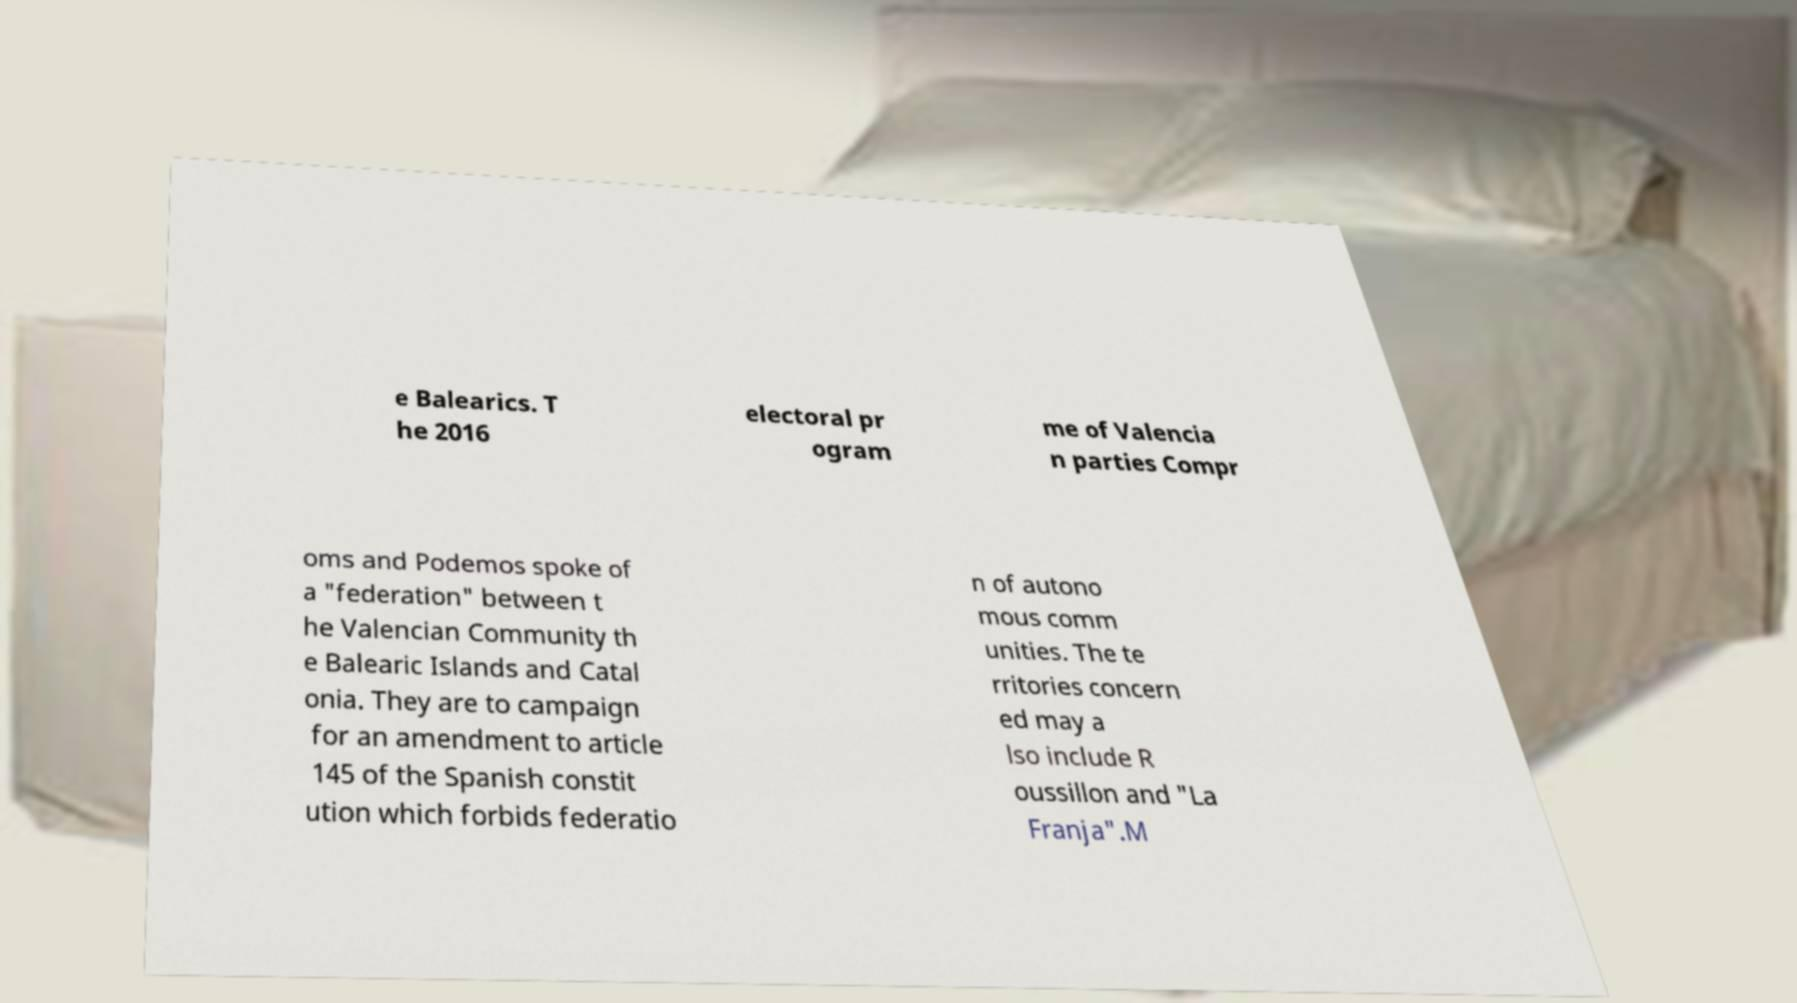I need the written content from this picture converted into text. Can you do that? e Balearics. T he 2016 electoral pr ogram me of Valencia n parties Compr oms and Podemos spoke of a "federation" between t he Valencian Community th e Balearic Islands and Catal onia. They are to campaign for an amendment to article 145 of the Spanish constit ution which forbids federatio n of autono mous comm unities. The te rritories concern ed may a lso include R oussillon and "La Franja".M 